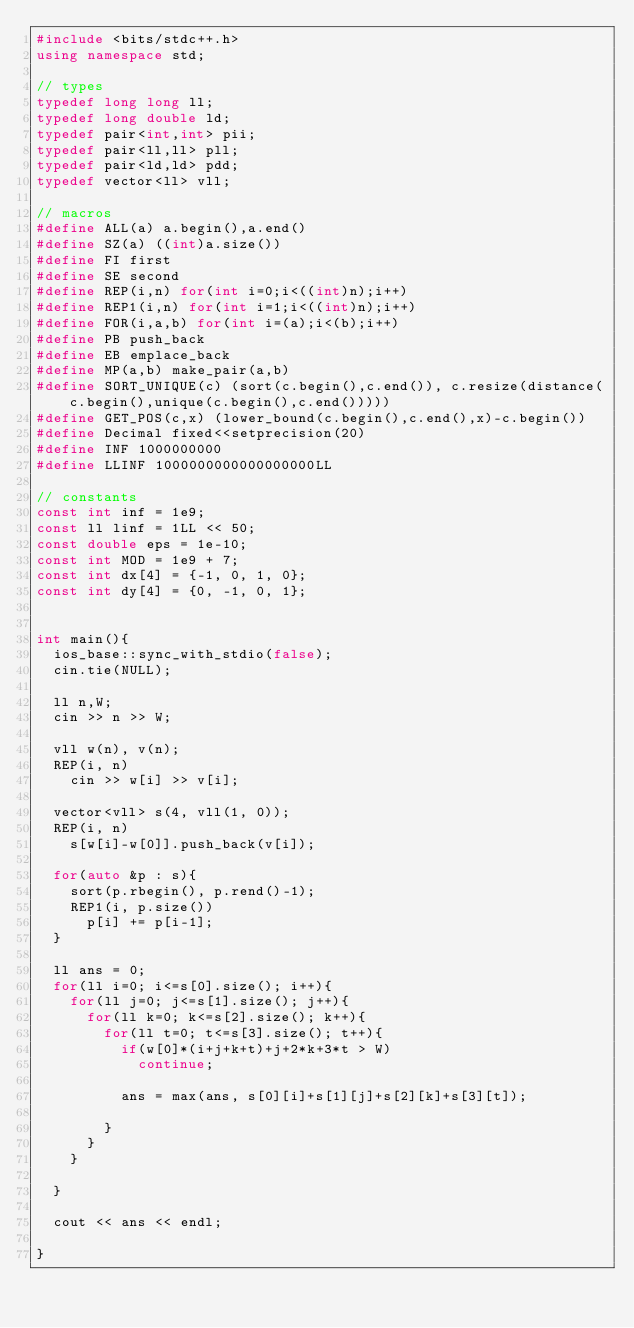Convert code to text. <code><loc_0><loc_0><loc_500><loc_500><_C++_>#include <bits/stdc++.h>
using namespace std;

// types
typedef long long ll;
typedef long double ld;
typedef pair<int,int> pii;
typedef pair<ll,ll> pll;
typedef pair<ld,ld> pdd;
typedef vector<ll> vll;

// macros
#define ALL(a) a.begin(),a.end()
#define SZ(a) ((int)a.size())
#define FI first
#define SE second
#define REP(i,n) for(int i=0;i<((int)n);i++)
#define REP1(i,n) for(int i=1;i<((int)n);i++)
#define FOR(i,a,b) for(int i=(a);i<(b);i++)
#define PB push_back
#define EB emplace_back
#define MP(a,b) make_pair(a,b)
#define SORT_UNIQUE(c) (sort(c.begin(),c.end()), c.resize(distance(c.begin(),unique(c.begin(),c.end()))))
#define GET_POS(c,x) (lower_bound(c.begin(),c.end(),x)-c.begin())
#define Decimal fixed<<setprecision(20)
#define INF 1000000000
#define LLINF 1000000000000000000LL

// constants
const int inf = 1e9;
const ll linf = 1LL << 50;
const double eps = 1e-10;
const int MOD = 1e9 + 7;
const int dx[4] = {-1, 0, 1, 0};
const int dy[4] = {0, -1, 0, 1};


int main(){
  ios_base::sync_with_stdio(false);
  cin.tie(NULL);

  ll n,W;
  cin >> n >> W;

  vll w(n), v(n);
  REP(i, n)
    cin >> w[i] >> v[i];

  vector<vll> s(4, vll(1, 0));
  REP(i, n)
    s[w[i]-w[0]].push_back(v[i]);

  for(auto &p : s){
    sort(p.rbegin(), p.rend()-1);
    REP1(i, p.size())
      p[i] += p[i-1];
  }

  ll ans = 0;
  for(ll i=0; i<=s[0].size(); i++){
    for(ll j=0; j<=s[1].size(); j++){
      for(ll k=0; k<=s[2].size(); k++){
        for(ll t=0; t<=s[3].size(); t++){
          if(w[0]*(i+j+k+t)+j+2*k+3*t > W)
            continue;

          ans = max(ans, s[0][i]+s[1][j]+s[2][k]+s[3][t]);

        }
      }
    }

  }

  cout << ans << endl;

}
</code> 